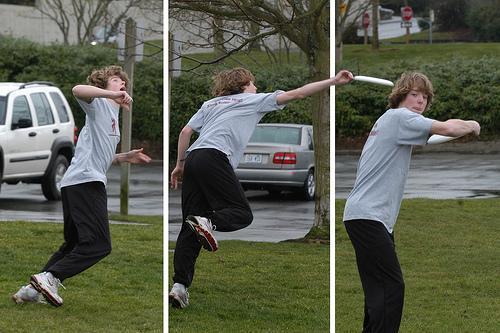In how many of these shots is the teen wearing the gray shirt touching the frisbee?
Give a very brief answer. 0. 